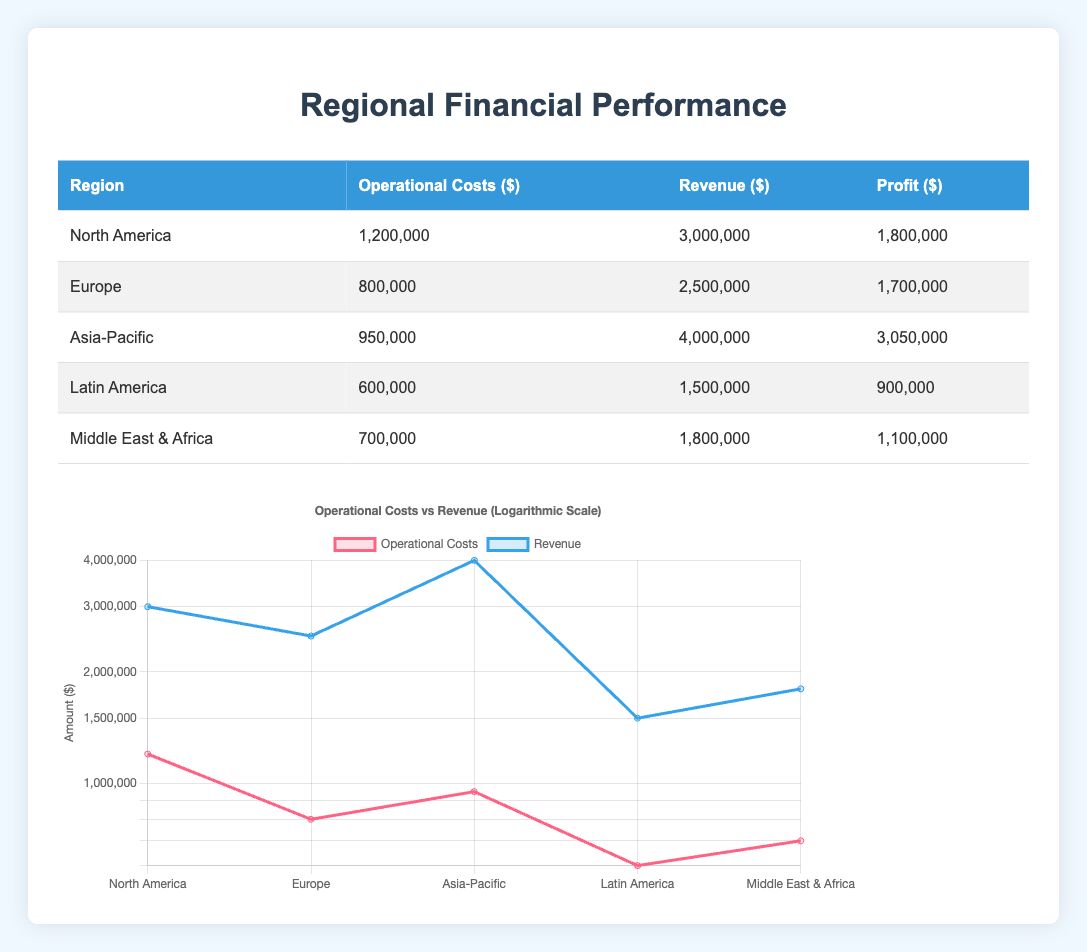What is the operational cost for Europe? According to the table, there is a specific entry for Europe that shows the operational costs amounting to $800,000.
Answer: 800,000 Which region has the highest revenue? The table lists the revenue for each region, and upon reviewing, Asia-Pacific has the highest revenue of $4,000,000, which is greater than all other regions.
Answer: Asia-Pacific What is the combined operational cost for all regions? To find the combined operational cost, sum the operational costs for each region: 1,200,000 + 800,000 + 950,000 + 600,000 + 700,000 = 3,250,000.
Answer: 3,250,000 Is the profit for Latin America greater than the operational costs? For Latin America, the operational costs are $600,000 and the profit is $900,000. Since $900,000 is greater than $600,000, the statement is true.
Answer: Yes What is the average profit across all regions? First, calculate the profit for each region: North America ($1,800,000), Europe ($1,700,000), Asia-Pacific ($3,050,000), Latin America ($900,000), and Middle East & Africa ($1,100,000). Adding these profits gives $8,550,000. Then, dividing by the number of regions (5) gives $1,710,000 as the average profit.
Answer: 1,710,000 How does the operational cost of North America compare to the average operational cost of all regions? The average operational cost is calculated by summing the operational costs ($3,250,000) and dividing by 5 (number of regions), which gives $650,000. North America's operational cost is $1,200,000, which is greater than the average of $650,000.
Answer: Greater Which region achieved a profit of less than $1,000,000? The profit for each region shows that Latin America has a profit of $900,000, which is less than $1,000,000, while the other regions have profits above this threshold.
Answer: Latin America Does Europe have a profit less than Asia-Pacific? The profit for Europe is $1,700,000, while for Asia-Pacific it is $3,050,000. Since $1,700,000 is less than $3,050,000, the statement is true.
Answer: Yes 